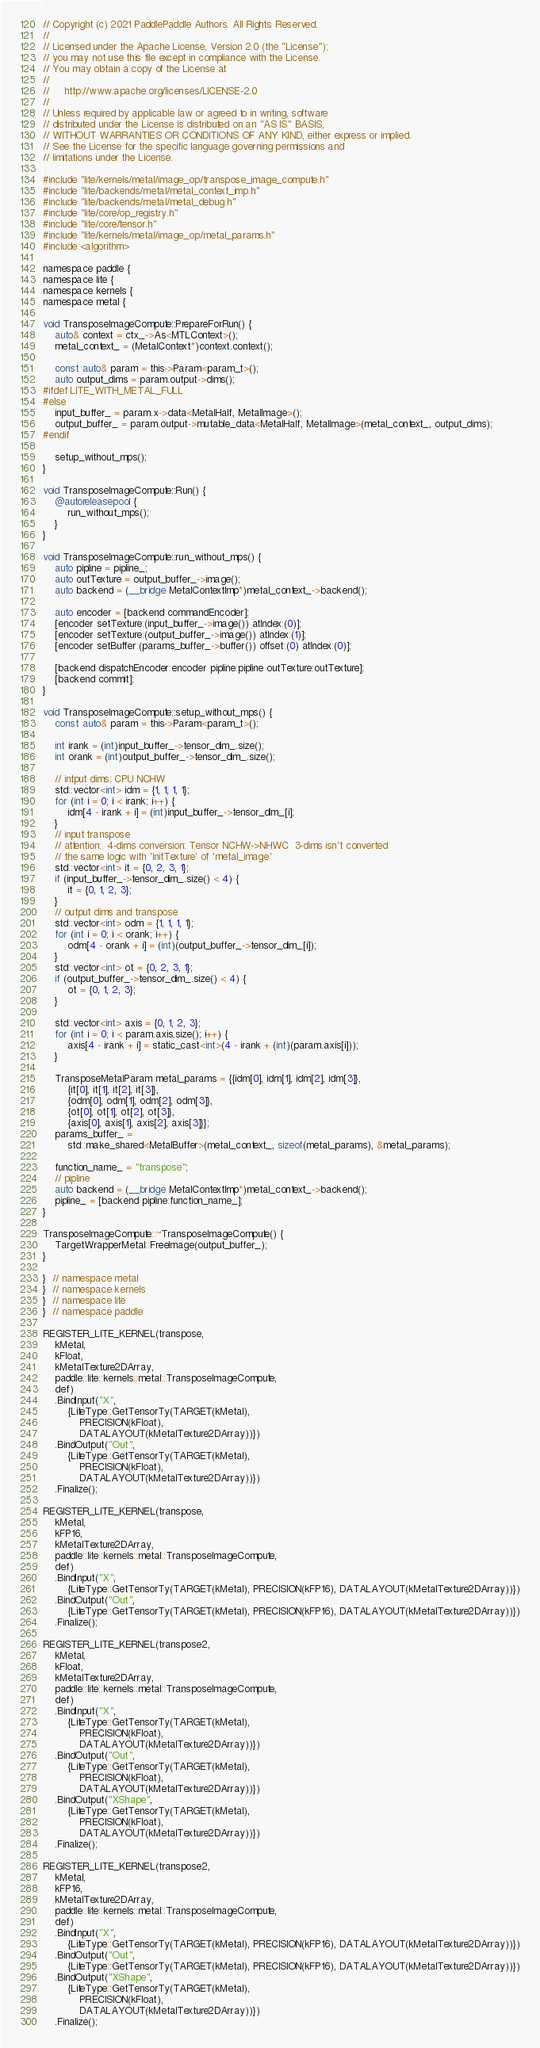Convert code to text. <code><loc_0><loc_0><loc_500><loc_500><_ObjectiveC_>// Copyright (c) 2021 PaddlePaddle Authors. All Rights Reserved.
//
// Licensed under the Apache License, Version 2.0 (the "License");
// you may not use this file except in compliance with the License.
// You may obtain a copy of the License at
//
//     http://www.apache.org/licenses/LICENSE-2.0
//
// Unless required by applicable law or agreed to in writing, software
// distributed under the License is distributed on an "AS IS" BASIS,
// WITHOUT WARRANTIES OR CONDITIONS OF ANY KIND, either express or implied.
// See the License for the specific language governing permissions and
// limitations under the License.

#include "lite/kernels/metal/image_op/transpose_image_compute.h"
#include "lite/backends/metal/metal_context_imp.h"
#include "lite/backends/metal/metal_debug.h"
#include "lite/core/op_registry.h"
#include "lite/core/tensor.h"
#include "lite/kernels/metal/image_op/metal_params.h"
#include <algorithm>

namespace paddle {
namespace lite {
namespace kernels {
namespace metal {

void TransposeImageCompute::PrepareForRun() {
    auto& context = ctx_->As<MTLContext>();
    metal_context_ = (MetalContext*)context.context();

    const auto& param = this->Param<param_t>();
    auto output_dims = param.output->dims();
#ifdef LITE_WITH_METAL_FULL
#else
    input_buffer_ = param.x->data<MetalHalf, MetalImage>();
    output_buffer_ = param.output->mutable_data<MetalHalf, MetalImage>(metal_context_, output_dims);
#endif

    setup_without_mps();
}

void TransposeImageCompute::Run() {
    @autoreleasepool {
        run_without_mps();
    }
}

void TransposeImageCompute::run_without_mps() {
    auto pipline = pipline_;
    auto outTexture = output_buffer_->image();
    auto backend = (__bridge MetalContextImp*)metal_context_->backend();

    auto encoder = [backend commandEncoder];
    [encoder setTexture:(input_buffer_->image()) atIndex:(0)];
    [encoder setTexture:(output_buffer_->image()) atIndex:(1)];
    [encoder setBuffer:(params_buffer_->buffer()) offset:(0) atIndex:(0)];

    [backend dispatchEncoder:encoder pipline:pipline outTexture:outTexture];
    [backend commit];
}

void TransposeImageCompute::setup_without_mps() {
    const auto& param = this->Param<param_t>();

    int irank = (int)input_buffer_->tensor_dim_.size();
    int orank = (int)output_buffer_->tensor_dim_.size();

    // intput dims: CPU NCHW
    std::vector<int> idm = {1, 1, 1, 1};
    for (int i = 0; i < irank; i++) {
        idm[4 - irank + i] = (int)input_buffer_->tensor_dim_[i];
    }
    // input transpose
    // attention:  4-dims conversion: Tensor NCHW->NHWC  3-dims isn't converted
    // the same logic with 'InitTexture' of 'metal_image'
    std::vector<int> it = {0, 2, 3, 1};
    if (input_buffer_->tensor_dim_.size() < 4) {
        it = {0, 1, 2, 3};
    }
    // output dims and transpose
    std::vector<int> odm = {1, 1, 1, 1};
    for (int i = 0; i < orank; i++) {
        odm[4 - orank + i] = (int)(output_buffer_->tensor_dim_[i]);
    }
    std::vector<int> ot = {0, 2, 3, 1};
    if (output_buffer_->tensor_dim_.size() < 4) {
        ot = {0, 1, 2, 3};
    }

    std::vector<int> axis = {0, 1, 2, 3};
    for (int i = 0; i < param.axis.size(); i++) {
        axis[4 - irank + i] = static_cast<int>(4 - irank + (int)(param.axis[i]));
    }

    TransposeMetalParam metal_params = {{idm[0], idm[1], idm[2], idm[3]},
        {it[0], it[1], it[2], it[3]},
        {odm[0], odm[1], odm[2], odm[3]},
        {ot[0], ot[1], ot[2], ot[3]},
        {axis[0], axis[1], axis[2], axis[3]}};
    params_buffer_ =
        std::make_shared<MetalBuffer>(metal_context_, sizeof(metal_params), &metal_params);

    function_name_ = "transpose";
    // pipline
    auto backend = (__bridge MetalContextImp*)metal_context_->backend();
    pipline_ = [backend pipline:function_name_];
}

TransposeImageCompute::~TransposeImageCompute() {
    TargetWrapperMetal::FreeImage(output_buffer_);
}

}  // namespace metal
}  // namespace kernels
}  // namespace lite
}  // namespace paddle

REGISTER_LITE_KERNEL(transpose,
    kMetal,
    kFloat,
    kMetalTexture2DArray,
    paddle::lite::kernels::metal::TransposeImageCompute,
    def)
    .BindInput("X",
        {LiteType::GetTensorTy(TARGET(kMetal),
            PRECISION(kFloat),
            DATALAYOUT(kMetalTexture2DArray))})
    .BindOutput("Out",
        {LiteType::GetTensorTy(TARGET(kMetal),
            PRECISION(kFloat),
            DATALAYOUT(kMetalTexture2DArray))})
    .Finalize();

REGISTER_LITE_KERNEL(transpose,
    kMetal,
    kFP16,
    kMetalTexture2DArray,
    paddle::lite::kernels::metal::TransposeImageCompute,
    def)
    .BindInput("X",
        {LiteType::GetTensorTy(TARGET(kMetal), PRECISION(kFP16), DATALAYOUT(kMetalTexture2DArray))})
    .BindOutput("Out",
        {LiteType::GetTensorTy(TARGET(kMetal), PRECISION(kFP16), DATALAYOUT(kMetalTexture2DArray))})
    .Finalize();

REGISTER_LITE_KERNEL(transpose2,
    kMetal,
    kFloat,
    kMetalTexture2DArray,
    paddle::lite::kernels::metal::TransposeImageCompute,
    def)
    .BindInput("X",
        {LiteType::GetTensorTy(TARGET(kMetal),
            PRECISION(kFloat),
            DATALAYOUT(kMetalTexture2DArray))})
    .BindOutput("Out",
        {LiteType::GetTensorTy(TARGET(kMetal),
            PRECISION(kFloat),
            DATALAYOUT(kMetalTexture2DArray))})
    .BindOutput("XShape",
        {LiteType::GetTensorTy(TARGET(kMetal),
            PRECISION(kFloat),
            DATALAYOUT(kMetalTexture2DArray))})
    .Finalize();

REGISTER_LITE_KERNEL(transpose2,
    kMetal,
    kFP16,
    kMetalTexture2DArray,
    paddle::lite::kernels::metal::TransposeImageCompute,
    def)
    .BindInput("X",
        {LiteType::GetTensorTy(TARGET(kMetal), PRECISION(kFP16), DATALAYOUT(kMetalTexture2DArray))})
    .BindOutput("Out",
        {LiteType::GetTensorTy(TARGET(kMetal), PRECISION(kFP16), DATALAYOUT(kMetalTexture2DArray))})
    .BindOutput("XShape",
        {LiteType::GetTensorTy(TARGET(kMetal),
            PRECISION(kFloat),
            DATALAYOUT(kMetalTexture2DArray))})
    .Finalize();
</code> 